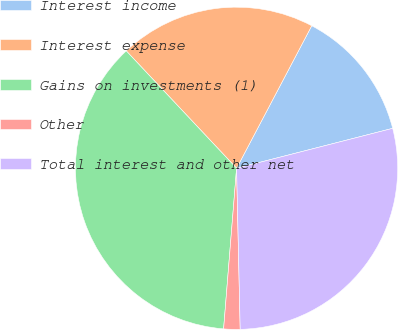<chart> <loc_0><loc_0><loc_500><loc_500><pie_chart><fcel>Interest income<fcel>Interest expense<fcel>Gains on investments (1)<fcel>Other<fcel>Total interest and other net<nl><fcel>13.29%<fcel>19.73%<fcel>36.71%<fcel>1.64%<fcel>28.63%<nl></chart> 